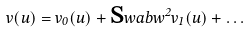Convert formula to latex. <formula><loc_0><loc_0><loc_500><loc_500>v ( u ) = v _ { 0 } ( u ) + \text  swab{w} ^ { 2 } v _ { 1 } ( u ) + \dots</formula> 